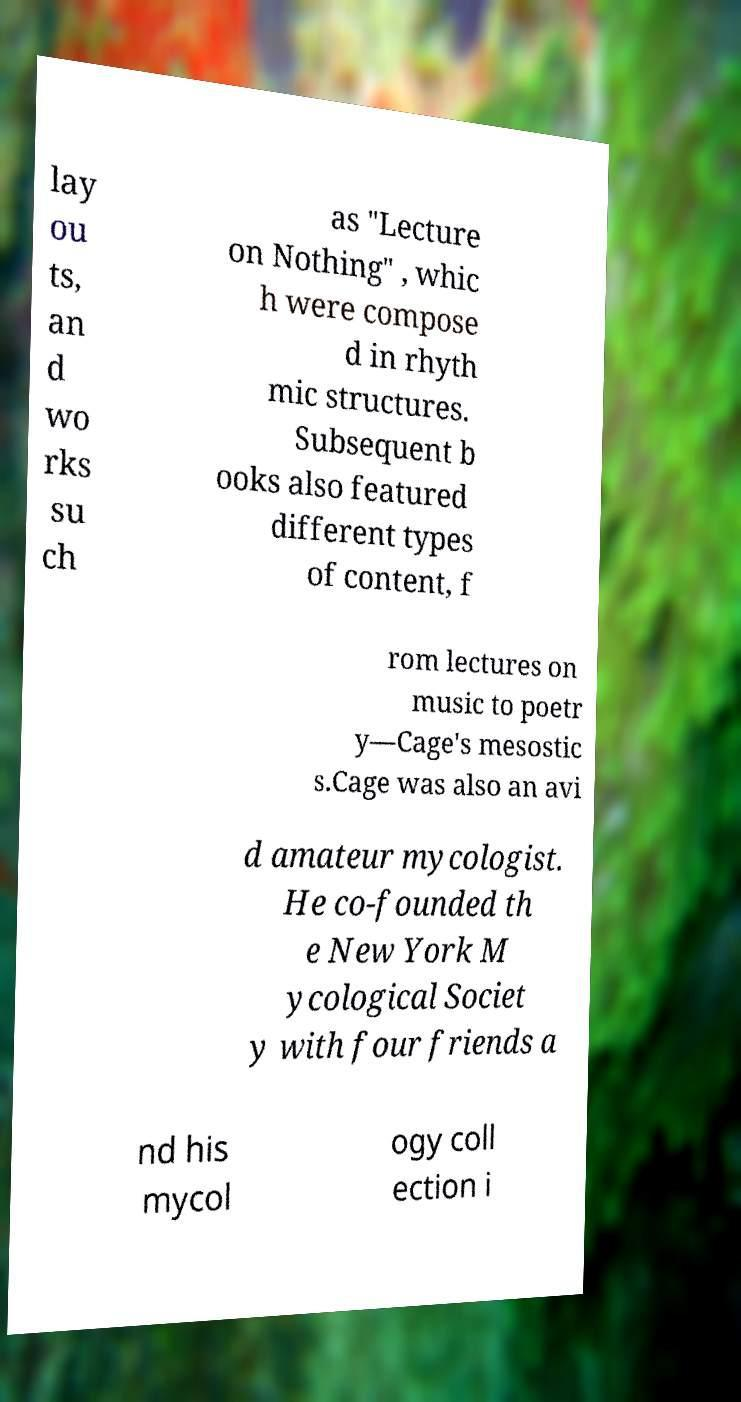For documentation purposes, I need the text within this image transcribed. Could you provide that? lay ou ts, an d wo rks su ch as "Lecture on Nothing" , whic h were compose d in rhyth mic structures. Subsequent b ooks also featured different types of content, f rom lectures on music to poetr y—Cage's mesostic s.Cage was also an avi d amateur mycologist. He co-founded th e New York M ycological Societ y with four friends a nd his mycol ogy coll ection i 